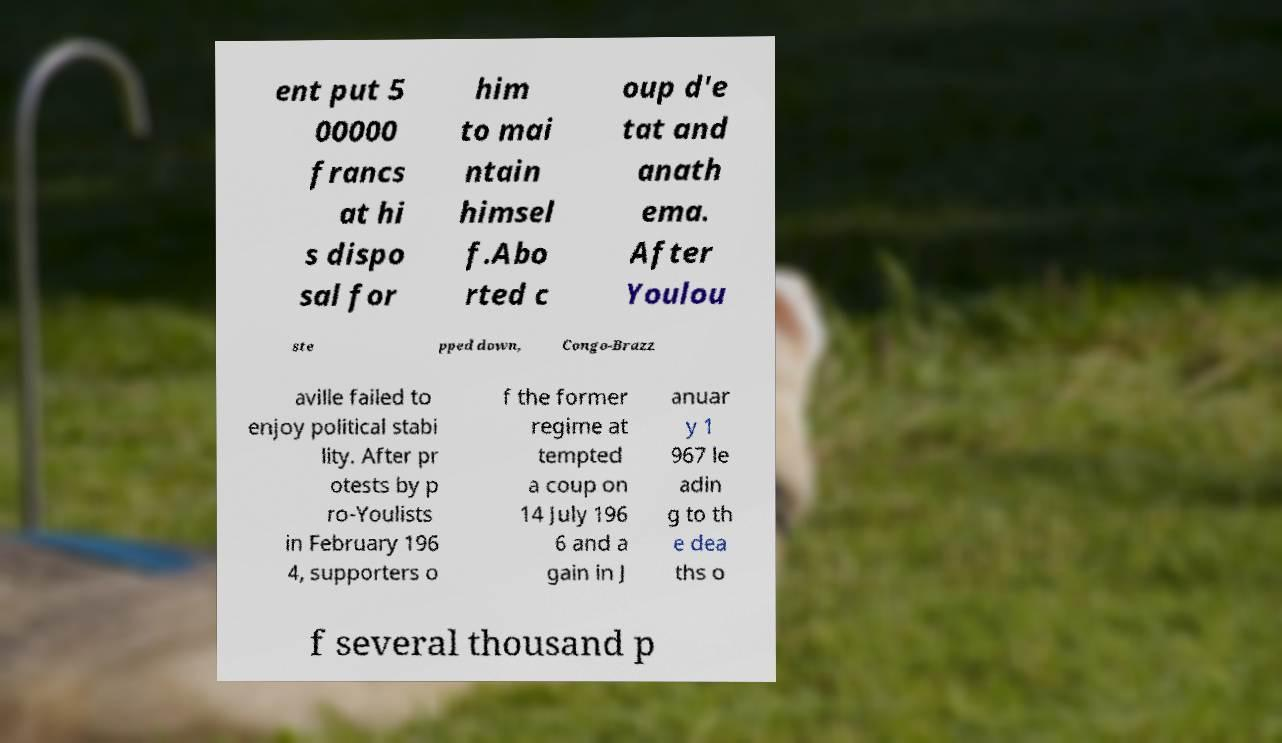Please identify and transcribe the text found in this image. ent put 5 00000 francs at hi s dispo sal for him to mai ntain himsel f.Abo rted c oup d'e tat and anath ema. After Youlou ste pped down, Congo-Brazz aville failed to enjoy political stabi lity. After pr otests by p ro-Youlists in February 196 4, supporters o f the former regime at tempted a coup on 14 July 196 6 and a gain in J anuar y 1 967 le adin g to th e dea ths o f several thousand p 